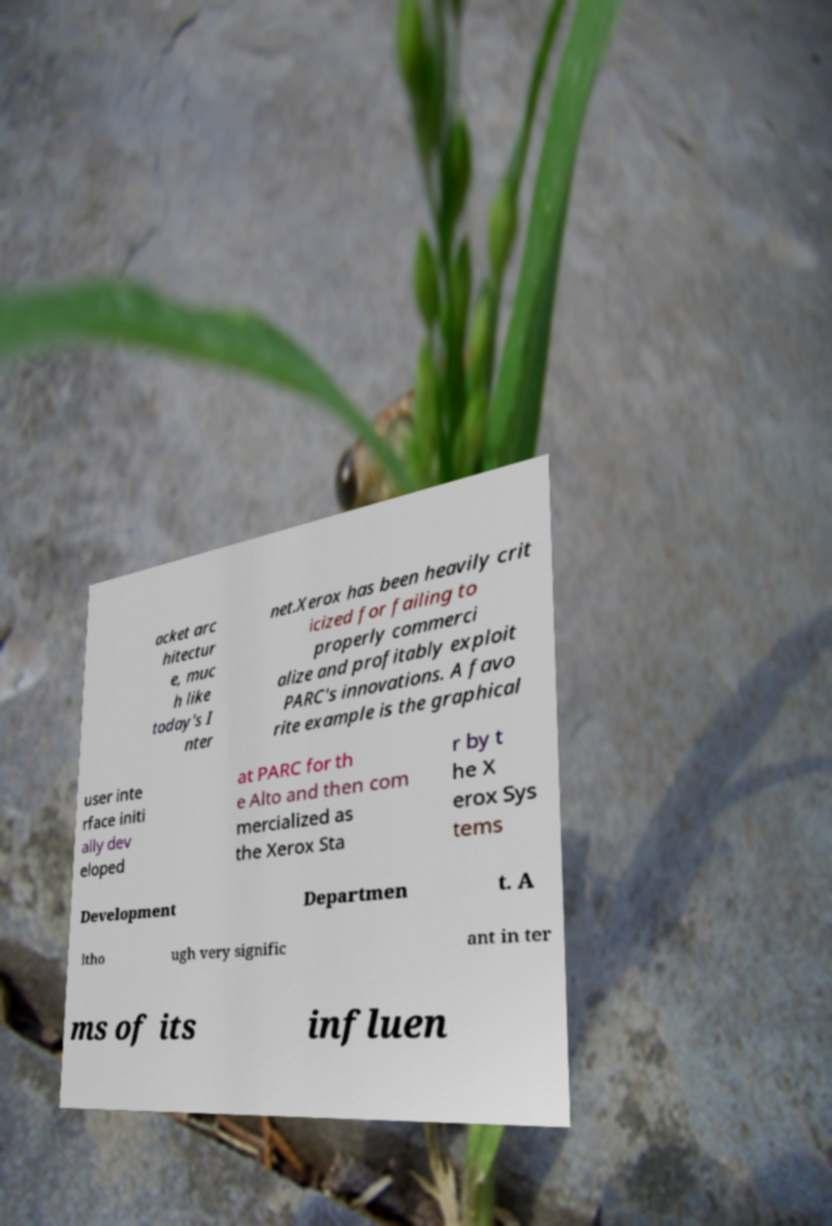Can you accurately transcribe the text from the provided image for me? acket arc hitectur e, muc h like today's I nter net.Xerox has been heavily crit icized for failing to properly commerci alize and profitably exploit PARC's innovations. A favo rite example is the graphical user inte rface initi ally dev eloped at PARC for th e Alto and then com mercialized as the Xerox Sta r by t he X erox Sys tems Development Departmen t. A ltho ugh very signific ant in ter ms of its influen 